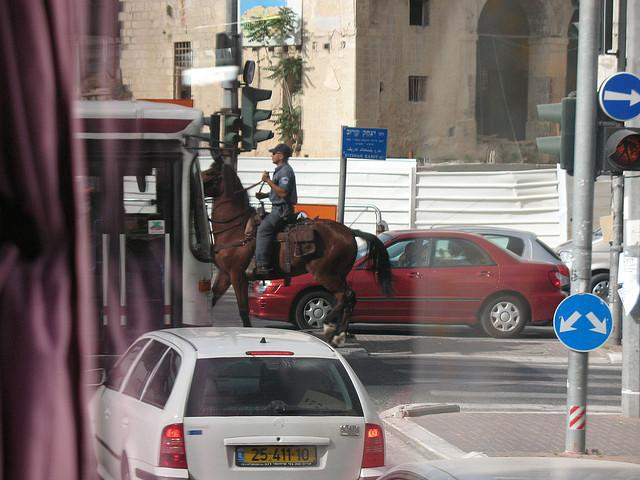What model is the red car? sedan 